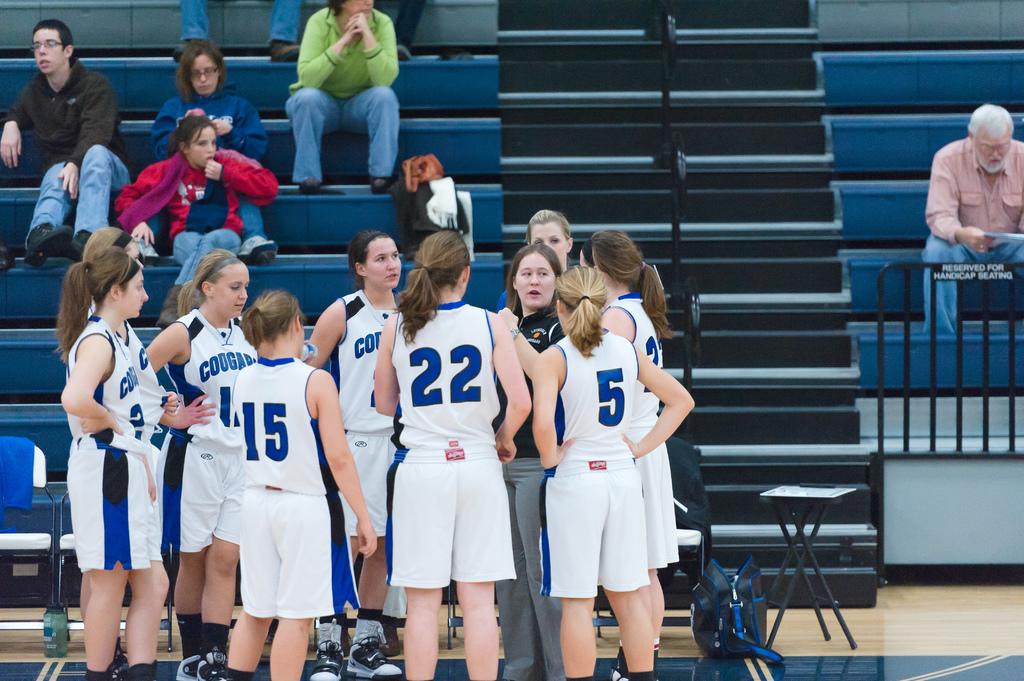What is the team name of the players huddled together?
Your answer should be very brief. Cougars. What is the number of the girl on the further right?
Give a very brief answer. 5. 